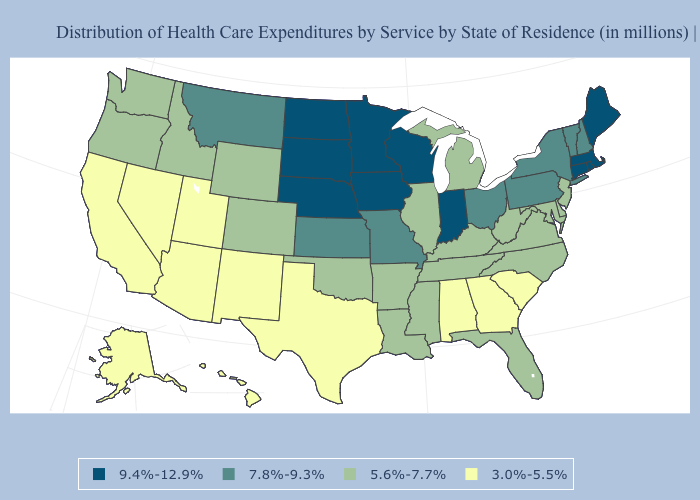Name the states that have a value in the range 5.6%-7.7%?
Short answer required. Arkansas, Colorado, Delaware, Florida, Idaho, Illinois, Kentucky, Louisiana, Maryland, Michigan, Mississippi, New Jersey, North Carolina, Oklahoma, Oregon, Tennessee, Virginia, Washington, West Virginia, Wyoming. What is the highest value in states that border Connecticut?
Quick response, please. 9.4%-12.9%. Among the states that border Missouri , does Kentucky have the lowest value?
Keep it brief. Yes. Name the states that have a value in the range 3.0%-5.5%?
Write a very short answer. Alabama, Alaska, Arizona, California, Georgia, Hawaii, Nevada, New Mexico, South Carolina, Texas, Utah. What is the value of South Carolina?
Keep it brief. 3.0%-5.5%. What is the lowest value in the South?
Give a very brief answer. 3.0%-5.5%. Does Alabama have a higher value than Rhode Island?
Short answer required. No. Among the states that border Arkansas , which have the highest value?
Write a very short answer. Missouri. Which states have the lowest value in the USA?
Give a very brief answer. Alabama, Alaska, Arizona, California, Georgia, Hawaii, Nevada, New Mexico, South Carolina, Texas, Utah. Name the states that have a value in the range 7.8%-9.3%?
Give a very brief answer. Kansas, Missouri, Montana, New Hampshire, New York, Ohio, Pennsylvania, Vermont. Does the first symbol in the legend represent the smallest category?
Write a very short answer. No. Does Connecticut have the same value as Iowa?
Keep it brief. Yes. Does the first symbol in the legend represent the smallest category?
Give a very brief answer. No. Does Montana have the highest value in the West?
Write a very short answer. Yes. What is the value of Maine?
Answer briefly. 9.4%-12.9%. 